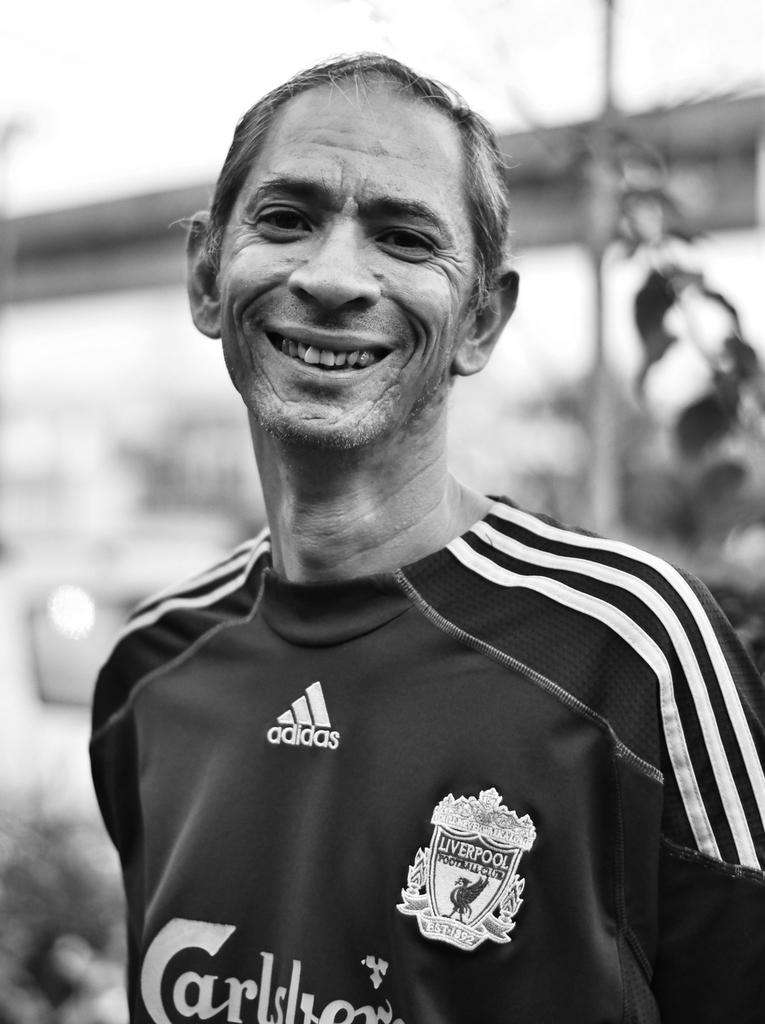<image>
Give a short and clear explanation of the subsequent image. Man wearing a jersey sponsored by Adidas and says Carlstown. 